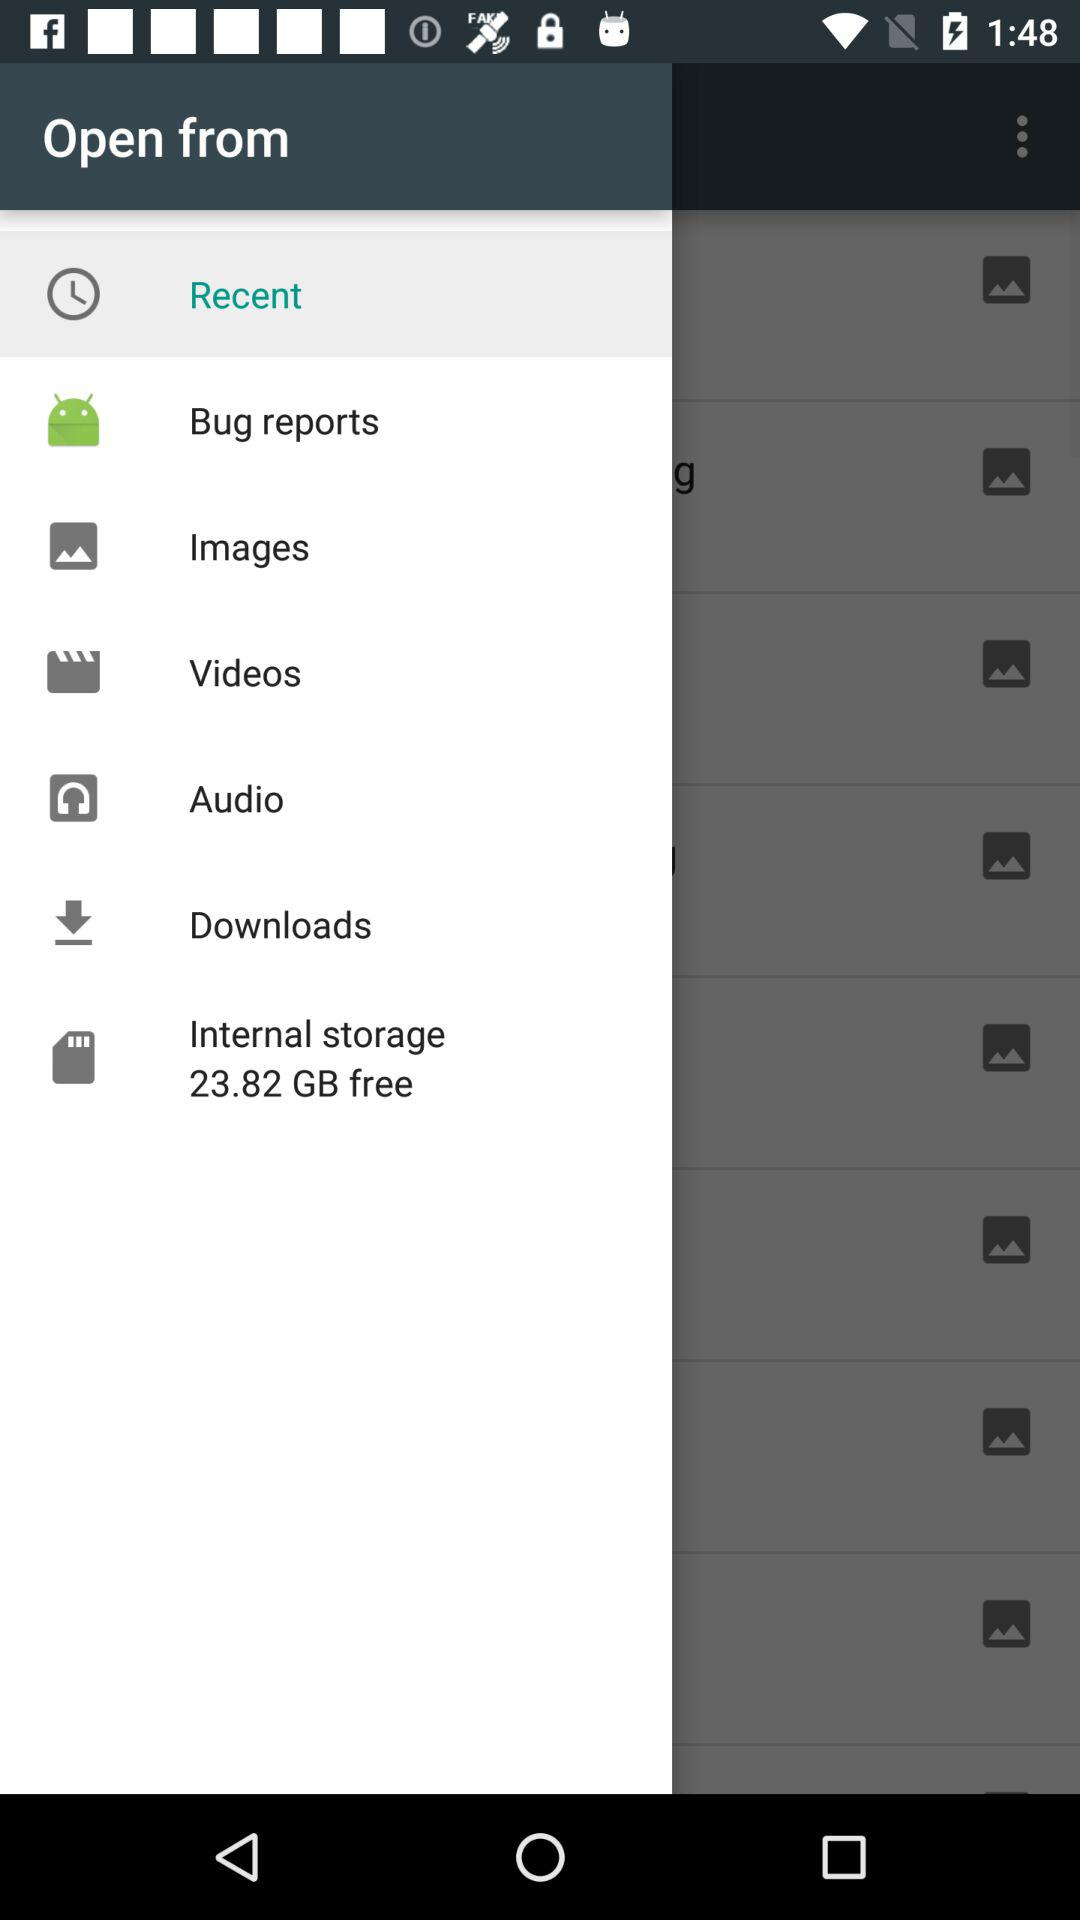How much space is free in internal storage? Internal storage has 23.82 GB of free space. 